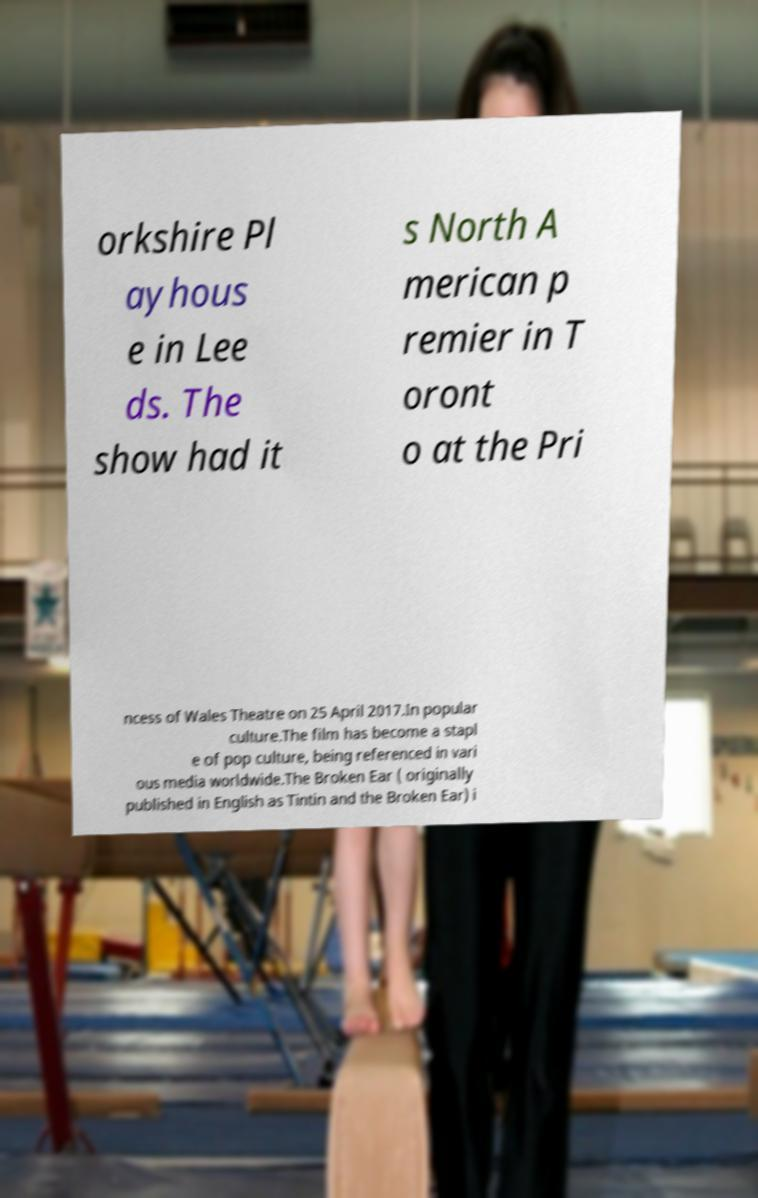There's text embedded in this image that I need extracted. Can you transcribe it verbatim? orkshire Pl ayhous e in Lee ds. The show had it s North A merican p remier in T oront o at the Pri ncess of Wales Theatre on 25 April 2017.In popular culture.The film has become a stapl e of pop culture, being referenced in vari ous media worldwide.The Broken Ear ( originally published in English as Tintin and the Broken Ear) i 